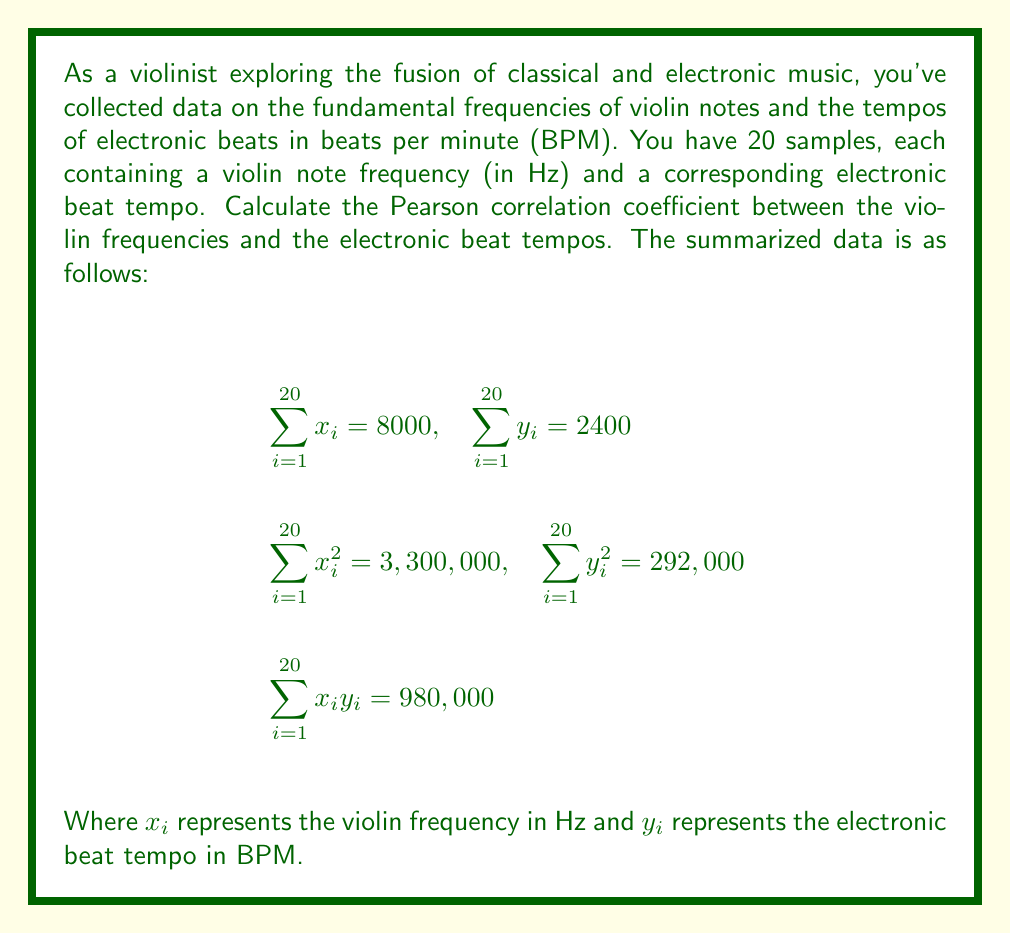Help me with this question. To calculate the Pearson correlation coefficient, we'll use the formula:

$$r = \frac{n\sum x_iy_i - (\sum x_i)(\sum y_i)}{\sqrt{[n\sum x_i^2 - (\sum x_i)^2][n\sum y_i^2 - (\sum y_i)^2]}}$$

Where $n$ is the number of samples, which is 20 in this case.

Let's substitute the given values:

$$r = \frac{20(980,000) - (8000)(2400)}{\sqrt{[20(3,300,000) - (8000)^2][20(292,000) - (2400)^2]}}$$

Now, let's calculate step by step:

1) Numerator:
   $20(980,000) - (8000)(2400) = 19,600,000 - 19,200,000 = 400,000$

2) Denominator:
   First part: $20(3,300,000) - (8000)^2 = 66,000,000 - 64,000,000 = 2,000,000$
   Second part: $20(292,000) - (2400)^2 = 5,840,000 - 5,760,000 = 80,000$

   $\sqrt{(2,000,000)(80,000)} = \sqrt{160,000,000,000} = 400,000$

3) Final calculation:
   $r = \frac{400,000}{400,000} = 1$

Therefore, the Pearson correlation coefficient is 1.
Answer: $r = 1$ 